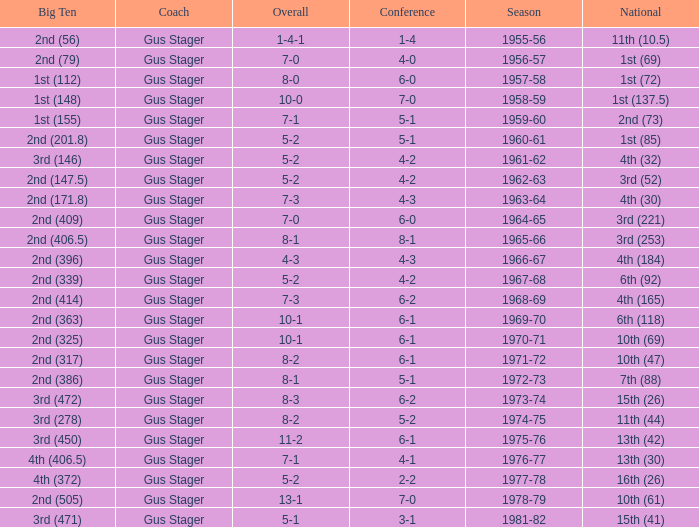What is the Season with a Big Ten that is 2nd (386)? 1972-73. 